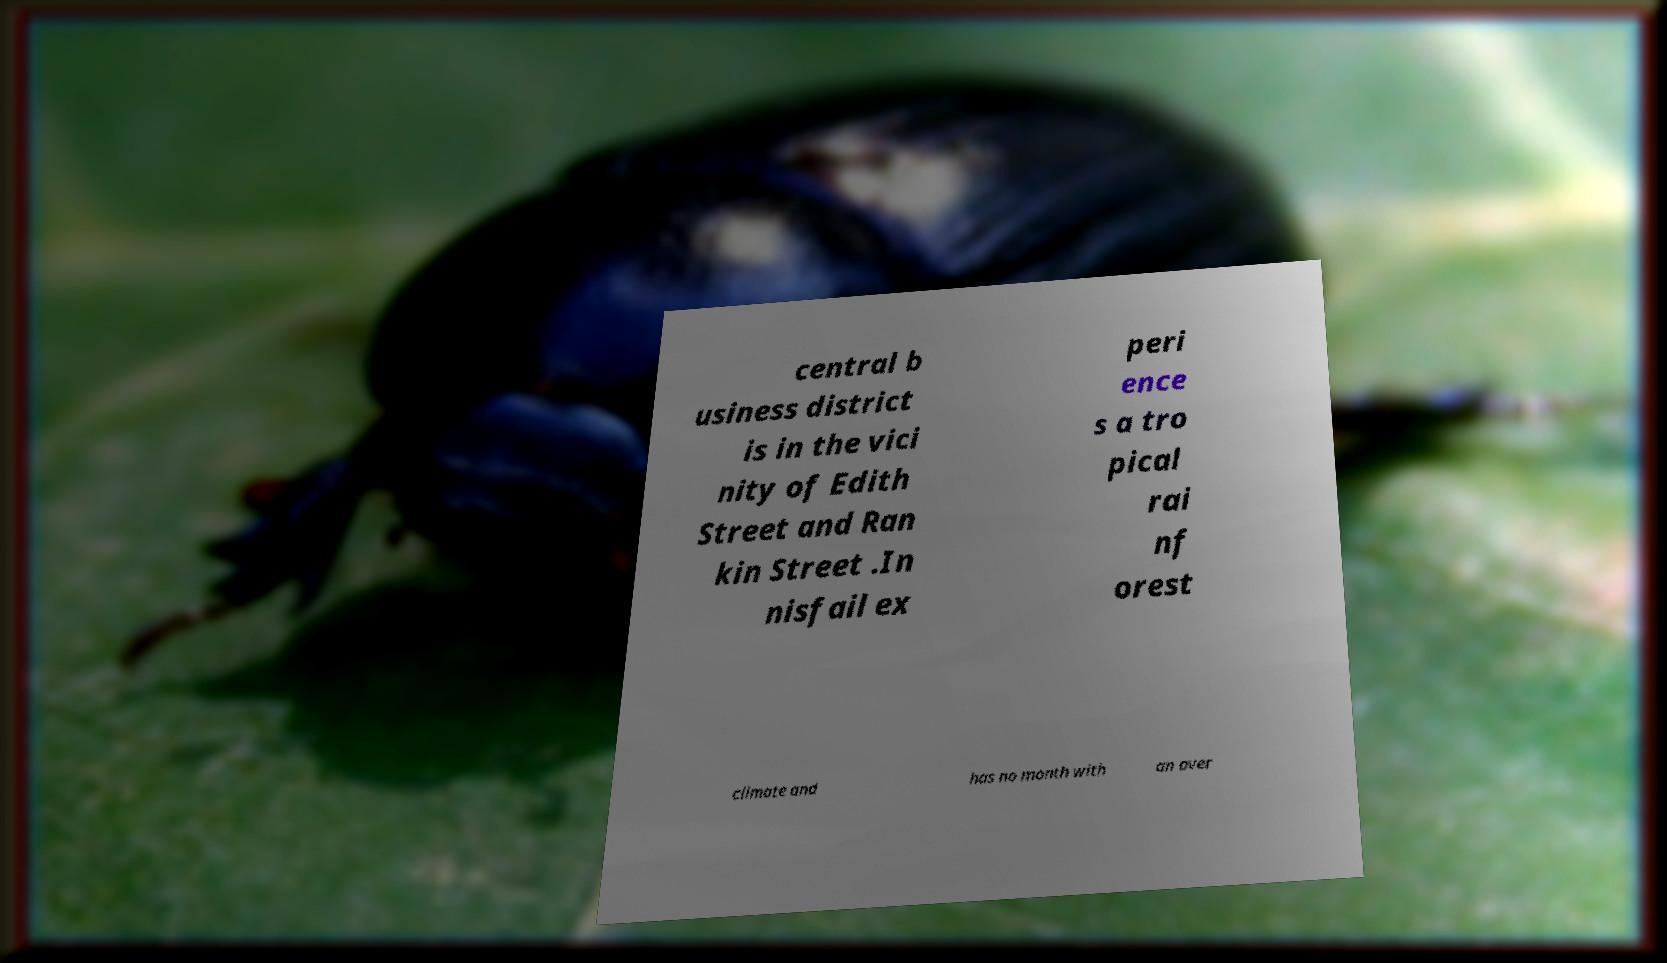There's text embedded in this image that I need extracted. Can you transcribe it verbatim? central b usiness district is in the vici nity of Edith Street and Ran kin Street .In nisfail ex peri ence s a tro pical rai nf orest climate and has no month with an aver 